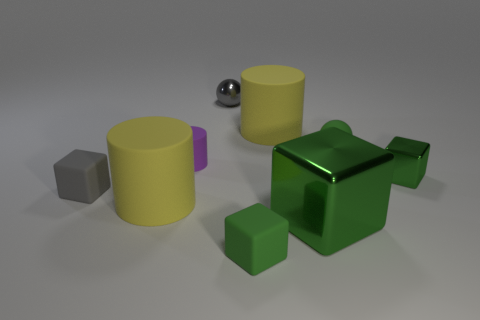Subtract all blue cylinders. How many green cubes are left? 3 Subtract 2 cubes. How many cubes are left? 2 Subtract all big yellow cylinders. How many cylinders are left? 1 Subtract all yellow blocks. Subtract all cyan spheres. How many blocks are left? 4 Add 1 large green objects. How many objects exist? 10 Subtract all cylinders. How many objects are left? 6 Add 2 tiny green matte cubes. How many tiny green matte cubes are left? 3 Add 5 gray blocks. How many gray blocks exist? 6 Subtract 0 brown cubes. How many objects are left? 9 Subtract all big gray blocks. Subtract all large green shiny blocks. How many objects are left? 8 